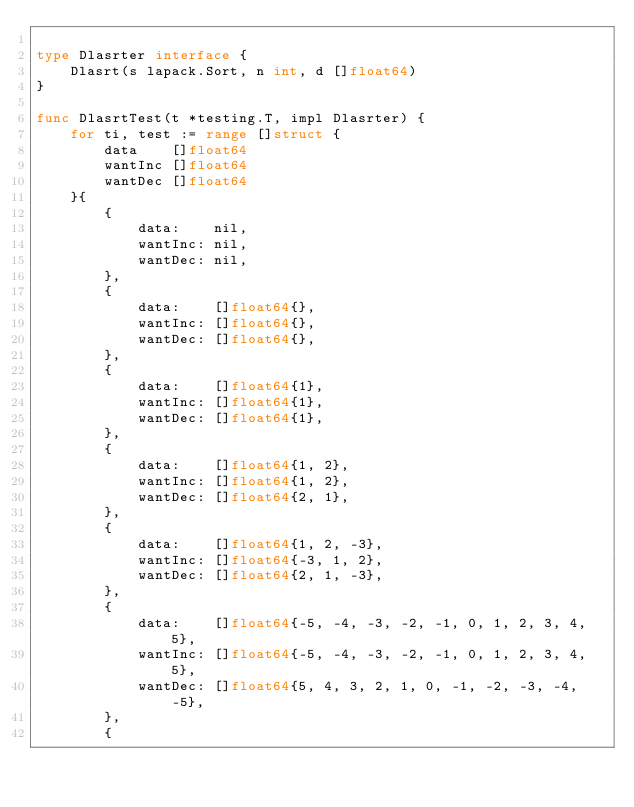Convert code to text. <code><loc_0><loc_0><loc_500><loc_500><_Go_>
type Dlasrter interface {
	Dlasrt(s lapack.Sort, n int, d []float64)
}

func DlasrtTest(t *testing.T, impl Dlasrter) {
	for ti, test := range []struct {
		data    []float64
		wantInc []float64
		wantDec []float64
	}{
		{
			data:    nil,
			wantInc: nil,
			wantDec: nil,
		},
		{
			data:    []float64{},
			wantInc: []float64{},
			wantDec: []float64{},
		},
		{
			data:    []float64{1},
			wantInc: []float64{1},
			wantDec: []float64{1},
		},
		{
			data:    []float64{1, 2},
			wantInc: []float64{1, 2},
			wantDec: []float64{2, 1},
		},
		{
			data:    []float64{1, 2, -3},
			wantInc: []float64{-3, 1, 2},
			wantDec: []float64{2, 1, -3},
		},
		{
			data:    []float64{-5, -4, -3, -2, -1, 0, 1, 2, 3, 4, 5},
			wantInc: []float64{-5, -4, -3, -2, -1, 0, 1, 2, 3, 4, 5},
			wantDec: []float64{5, 4, 3, 2, 1, 0, -1, -2, -3, -4, -5},
		},
		{</code> 